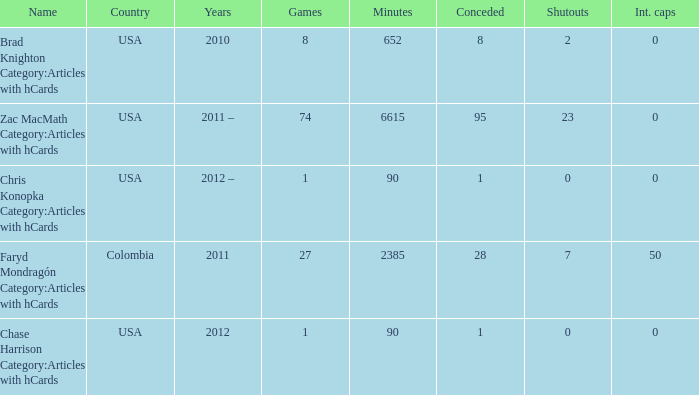What is the lowest overall amount of shutouts? 0.0. 